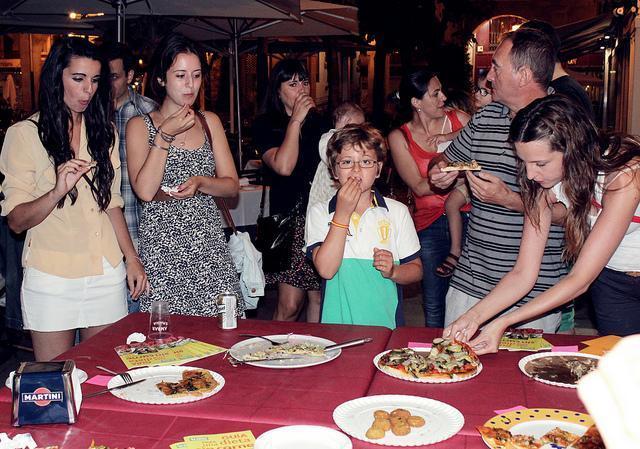How many handbags are there?
Give a very brief answer. 3. How many umbrellas are in the photo?
Give a very brief answer. 2. How many people are visible?
Give a very brief answer. 8. How many trains are in the photo?
Give a very brief answer. 0. 